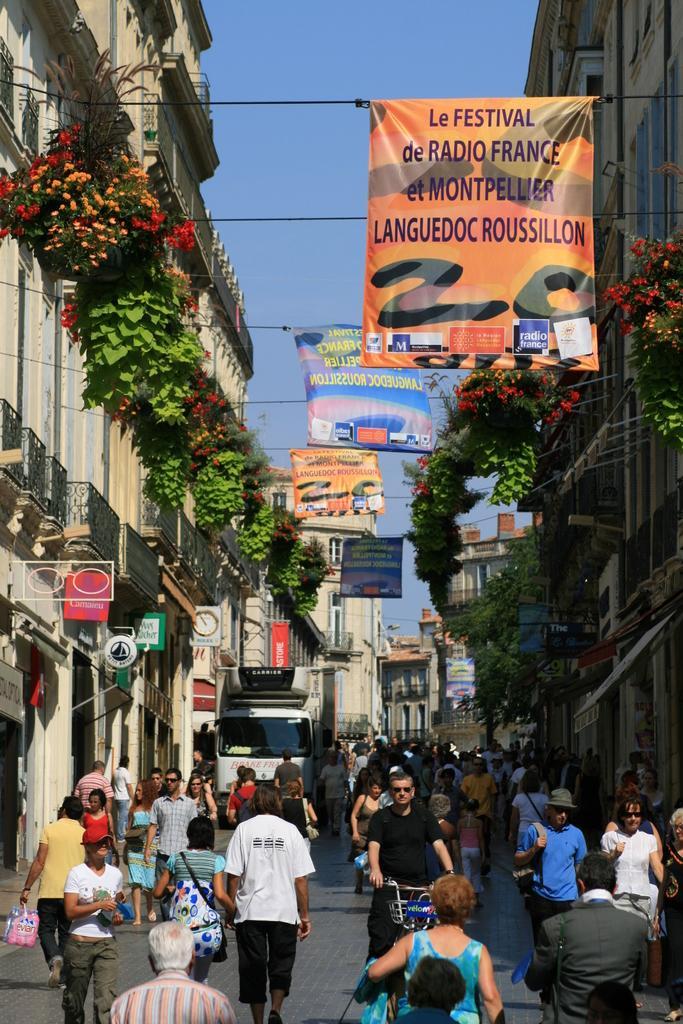How would you summarize this image in a sentence or two? In this picture we can see a group of people, vehicle and a bicycle on the ground and in the background we can see buildings, banners, plants with flowers, sky and some objects. 